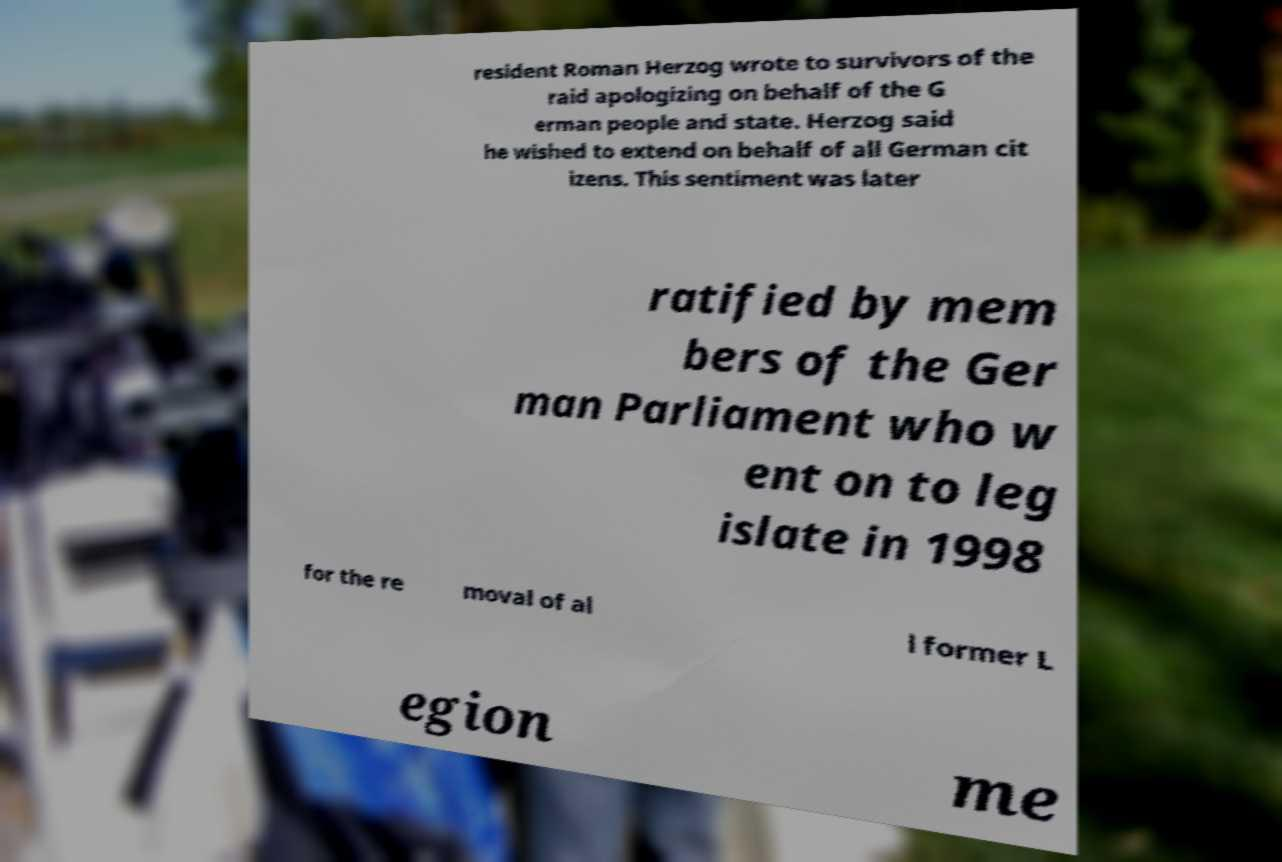Can you accurately transcribe the text from the provided image for me? resident Roman Herzog wrote to survivors of the raid apologizing on behalf of the G erman people and state. Herzog said he wished to extend on behalf of all German cit izens. This sentiment was later ratified by mem bers of the Ger man Parliament who w ent on to leg islate in 1998 for the re moval of al l former L egion me 